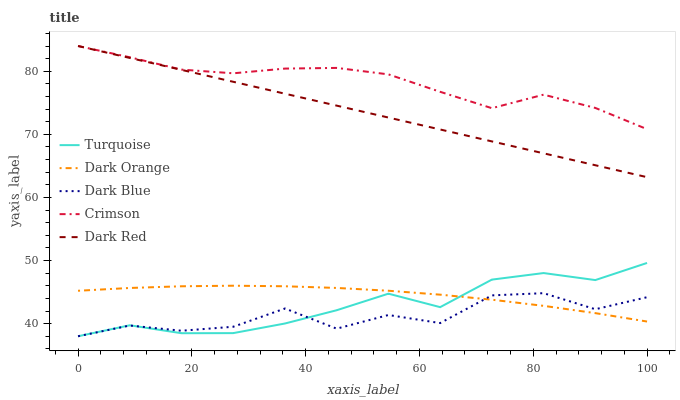Does Dark Blue have the minimum area under the curve?
Answer yes or no. Yes. Does Crimson have the maximum area under the curve?
Answer yes or no. Yes. Does Dark Orange have the minimum area under the curve?
Answer yes or no. No. Does Dark Orange have the maximum area under the curve?
Answer yes or no. No. Is Dark Red the smoothest?
Answer yes or no. Yes. Is Dark Blue the roughest?
Answer yes or no. Yes. Is Dark Orange the smoothest?
Answer yes or no. No. Is Dark Orange the roughest?
Answer yes or no. No. Does Turquoise have the lowest value?
Answer yes or no. Yes. Does Dark Orange have the lowest value?
Answer yes or no. No. Does Dark Red have the highest value?
Answer yes or no. Yes. Does Dark Orange have the highest value?
Answer yes or no. No. Is Dark Orange less than Dark Red?
Answer yes or no. Yes. Is Dark Red greater than Dark Orange?
Answer yes or no. Yes. Does Dark Red intersect Crimson?
Answer yes or no. Yes. Is Dark Red less than Crimson?
Answer yes or no. No. Is Dark Red greater than Crimson?
Answer yes or no. No. Does Dark Orange intersect Dark Red?
Answer yes or no. No. 